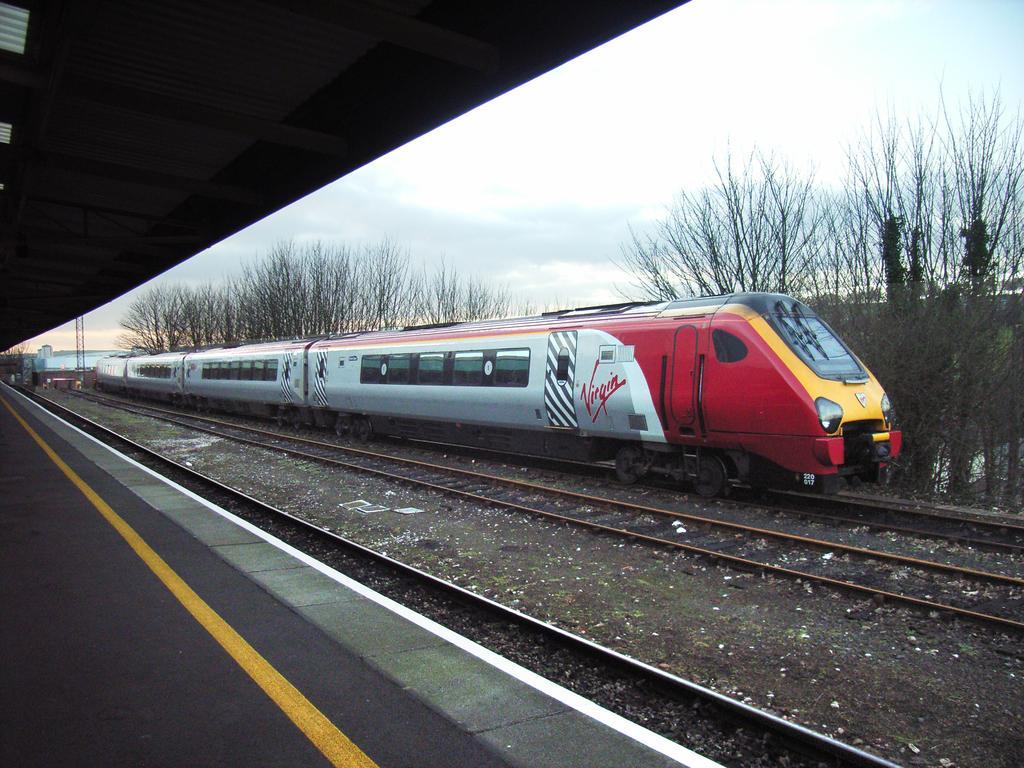Can you describe this image briefly? In this picture we can observe a train which is in red and silver color moving on the railway track. There are two other railway tracks. We can observe a platform. In the background there are trees and sky with some clouds 